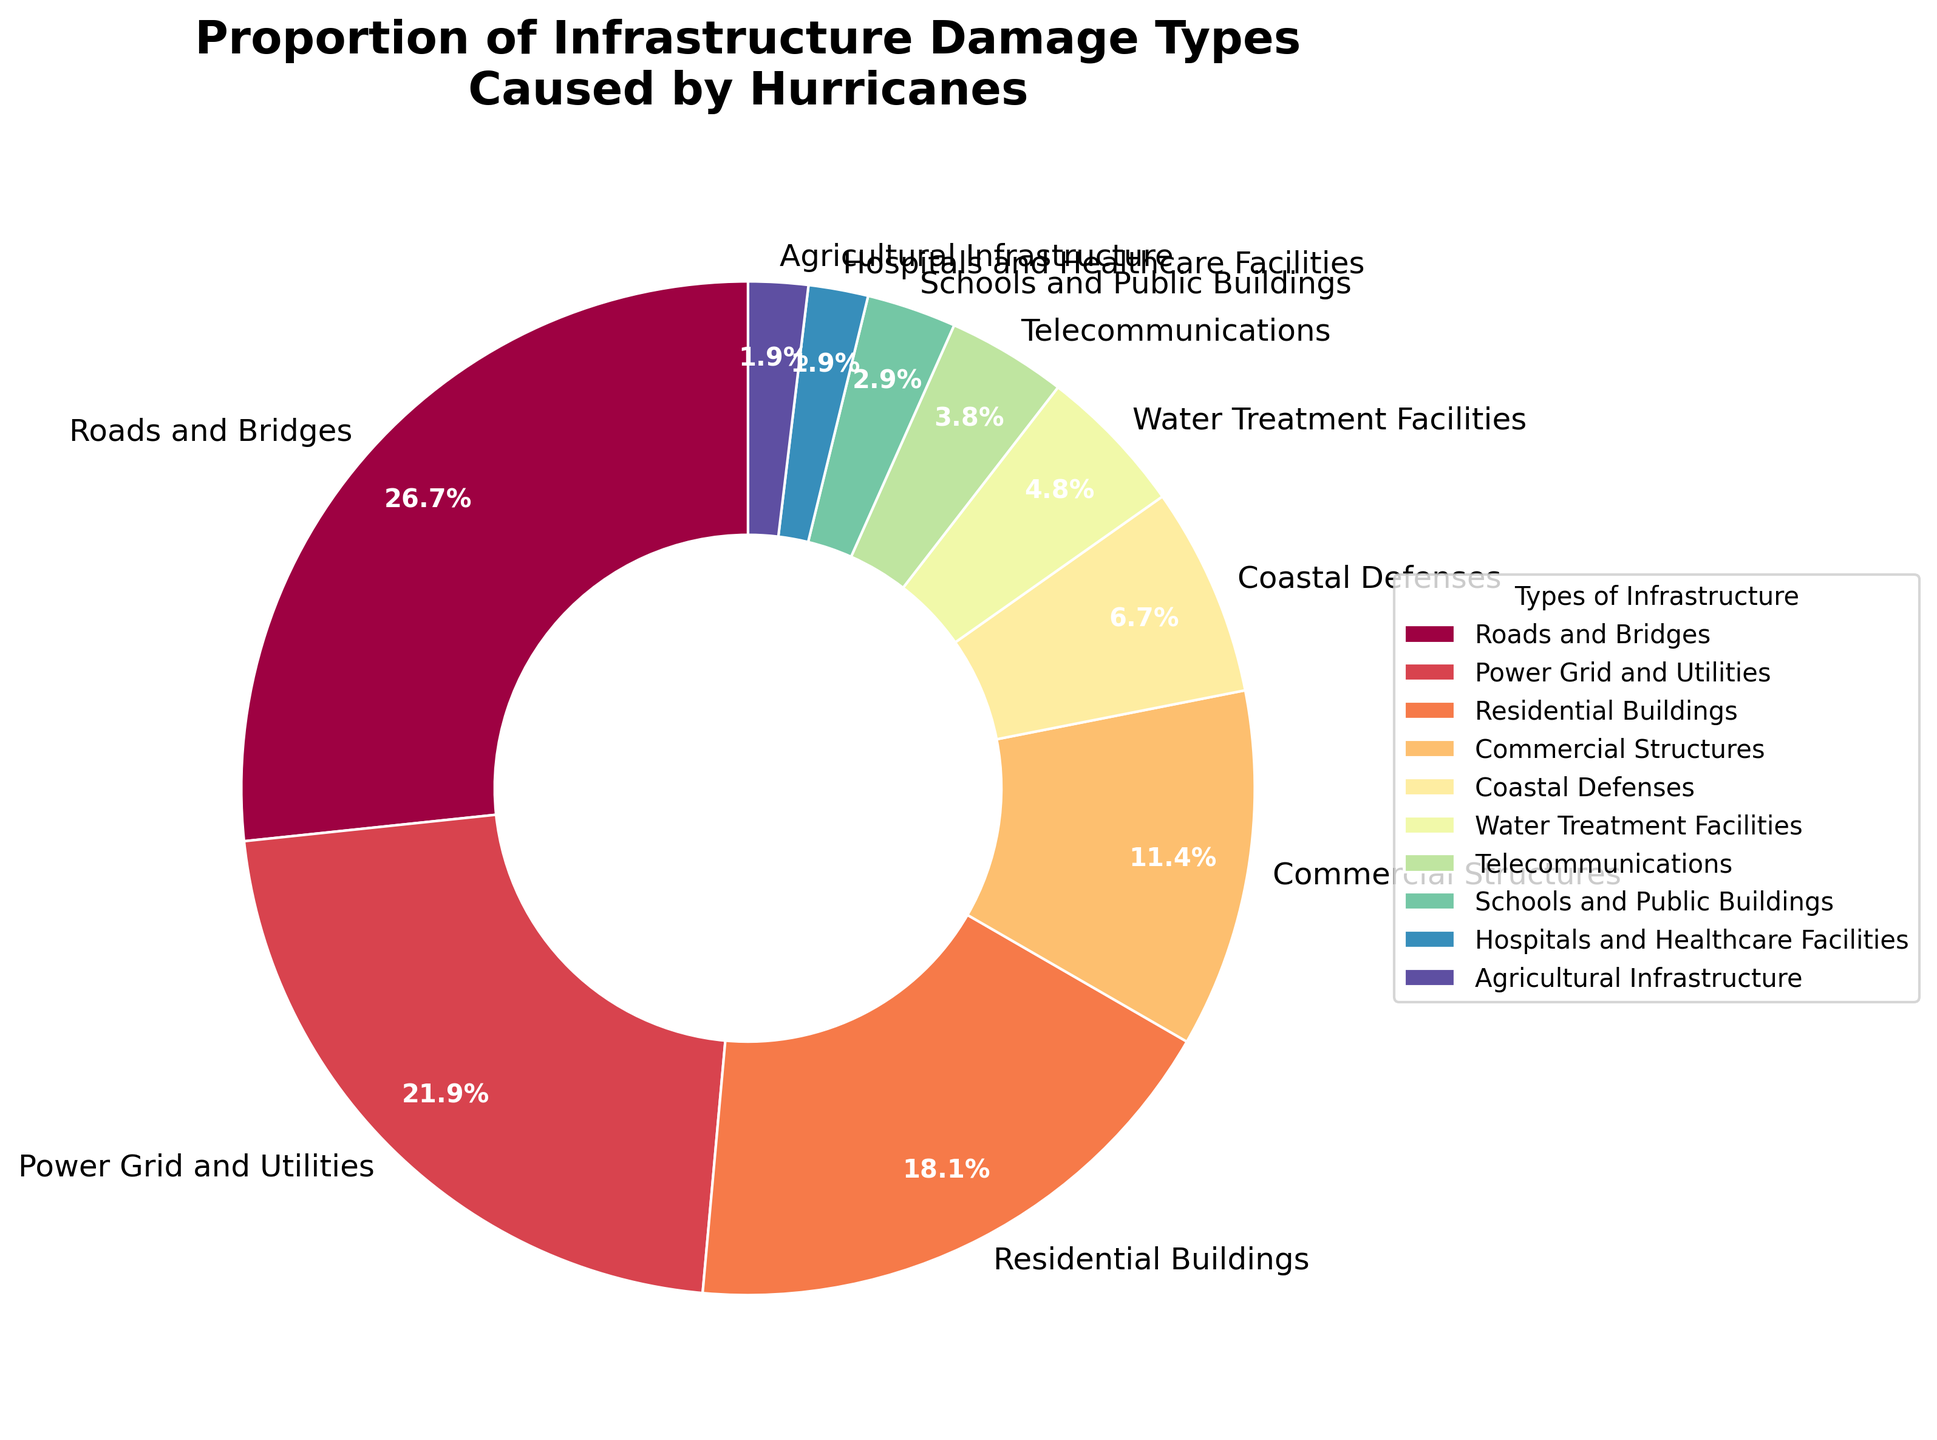What type of infrastructure has the highest proportion of damage? The figure shows that Roads and Bridges have the largest section of the pie chart.
Answer: Roads and Bridges How much more damage is done to Roads and Bridges than Telecommunications? The figure shows Roads and Bridges at 28% and Telecommunications at 4%. The difference is 28% - 4% = 24%.
Answer: 24% Which infrastructure types have the least damage, and what is their combined percentage? The smallest sections of the pie chart are Hospitals and Healthcare Facilities and Agricultural Infrastructure, each at 2%. Combined, they make up 2% + 2% = 4%.
Answer: Hospitals and Healthcare Facilities and Agricultural Infrastructure, 4% What is the combined damage percentage for Residential Buildings and Commercial Structures? The figure shows Residential Buildings at 19% and Commercial Structures at 12%. Their combined total is 19% + 12% = 31%.
Answer: 31% Which two infrastructure types together make up almost a third of the total damage? By closely examining the pie chart, Roads and Bridges (28%) and Power Grid and Utilities (23%) together account for a large portion of the chart. Their combined total is 28% + 23% = 51%, which is more than a third. Another close combination is Residential Buildings (19%) and Commercial Structures (12%), adding up to 31%.
Answer: Residential Buildings and Commercial Structures Among Coastal Defenses, Water Treatment Facilities, and Telecommunications, which has the highest proportion of damage? The figure shows Coastal Defenses at 7%, Water Treatment Facilities at 5%, and Telecommunications at 4%. Among these, Coastal Defenses has the highest percentage.
Answer: Coastal Defenses Are there more types of infrastructure with damage less than 10% or more than 10%? Enumerating the sections, less than 10% includes Coastal Defenses, Water Treatment Facilities, Telecommunications, Schools and Public Buildings, Hospitals and Healthcare Facilities, and Agricultural Infrastructure (6 sections). More than 10% includes Roads and Bridges, Power Grid and Utilities, Residential Buildings, and Commercial Structures (4 sections).
Answer: Less than 10% What is the percentage difference between Power Grid and Utilities damage and Schools and Public Buildings damage? The chart shows Power Grid and Utilities at 23% and Schools and Public Buildings at 3%. The difference is 23% - 3% = 20%.
Answer: 20% If the damage to Commercial Structures were to double, what percentage of the total damage would it then account for? Commercial Structures currently account for 12%. If doubled, it would be 12% * 2 = 24%.
Answer: 24% How do the visual sizes of Power Grid and Utilities and Residential Buildings compare? The sectors for Power Grid and Utilities (23%) and Residential Buildings (19%) indicate that Power Grid and Utilities has a larger visual size compared to Residential Buildings.
Answer: Power Grid and Utilities is larger 